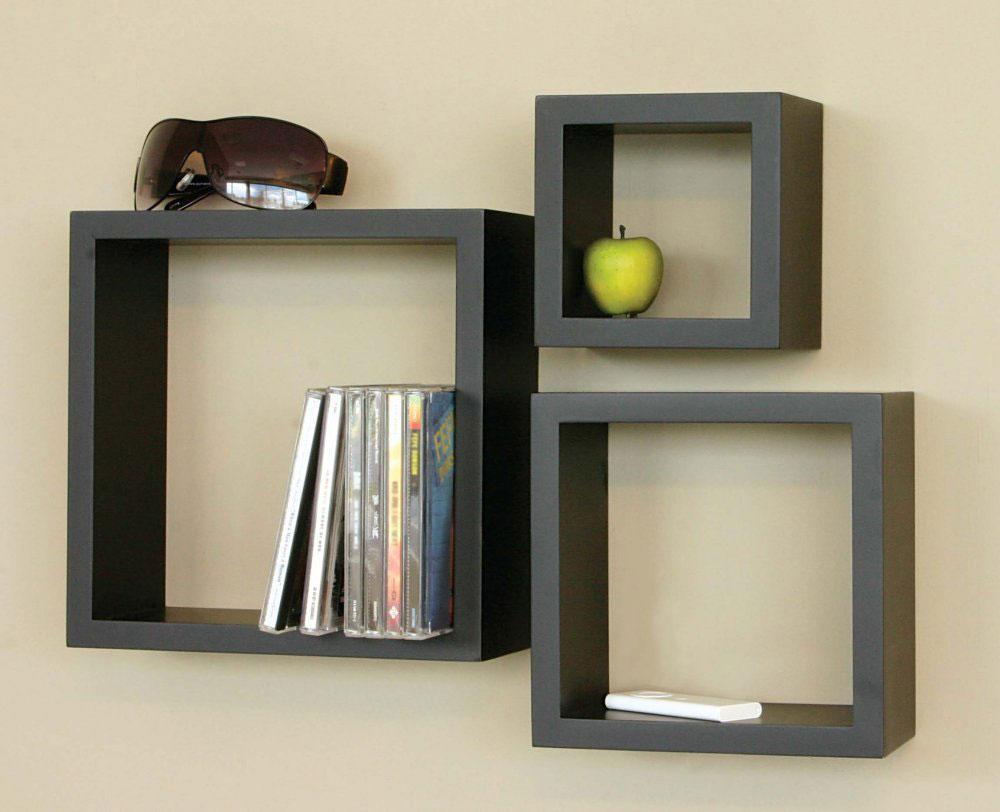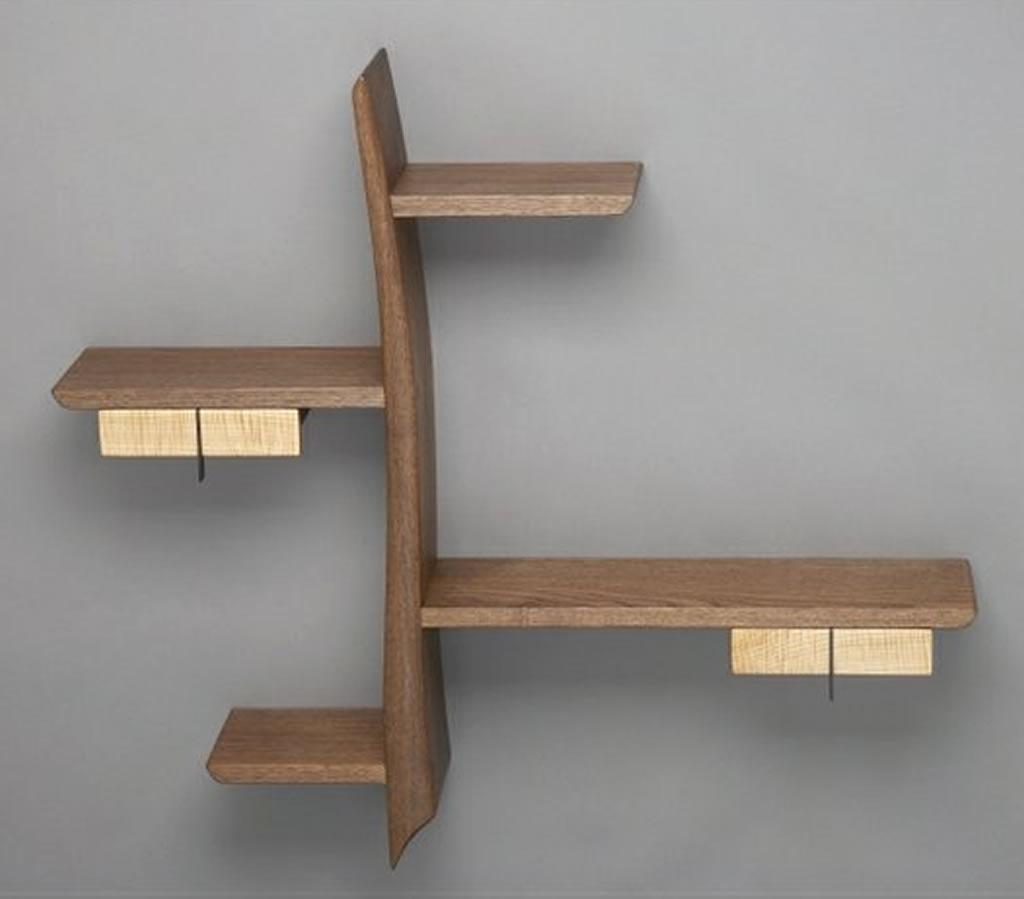The first image is the image on the left, the second image is the image on the right. Given the left and right images, does the statement "Each shelf unit holds some type of items, and one of the units has a single horizontal shelf." hold true? Answer yes or no. No. The first image is the image on the left, the second image is the image on the right. Assess this claim about the two images: "The shelf in one of the images is completely black.". Correct or not? Answer yes or no. Yes. 